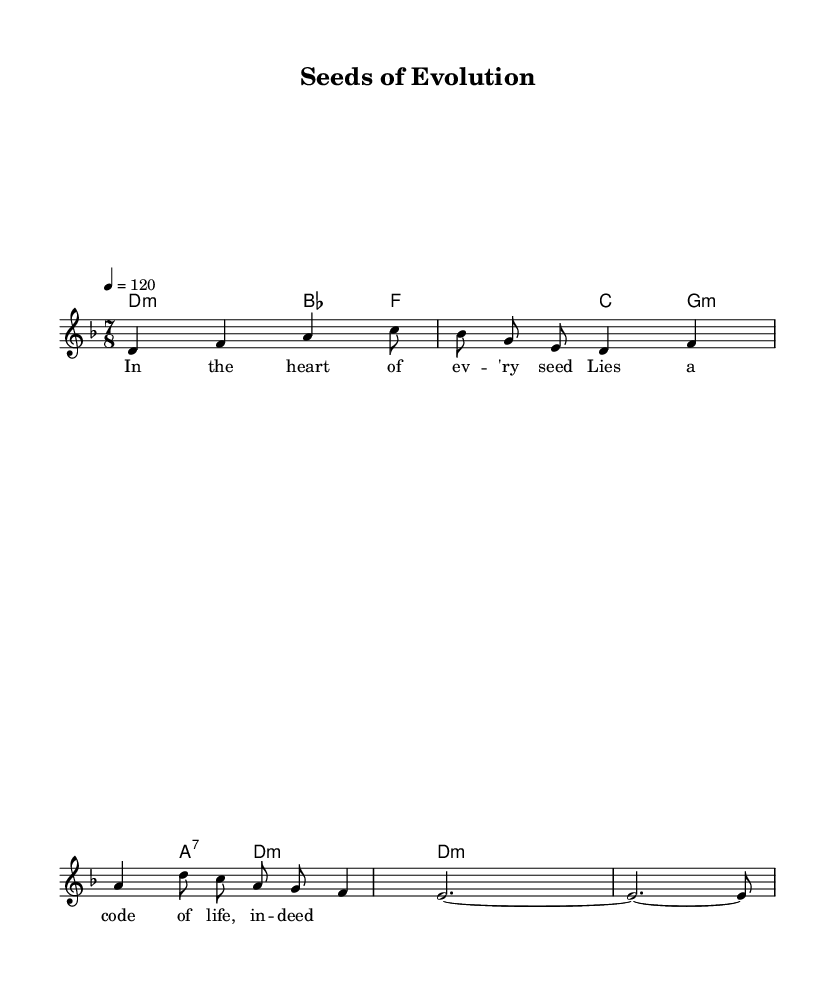What is the key signature of this music? The key signature is indicated at the beginning of the score. It shows that there are two flats: B flat and E flat, which corresponds to D minor, the key signature here.
Answer: D minor What is the time signature of this music? The time signature is located next to the key signature at the beginning of the score. It shows 7/8, indicating that there are seven beats per measure, and the eighth note gets one beat.
Answer: 7/8 What is the tempo marking of this music? The tempo marking is found above the staff, denoting the speed of the piece. It states "4 = 120," meaning there are 120 beats per minute, with a quarter note representing one beat.
Answer: 120 How many measures are in the melody? By counting the total number of measure bars present in the melody line, we find there are six measures.
Answer: 6 What type of chords are in the harmonies section? By analyzing the chord symbols, we can identify the types. The chords listed are D minor, B flat major, F major, G minor, A major 7, and D minor, indicating variations of minor and major chords.
Answer: Minor and Major What is the lyrical theme of the song? The lyrics discuss elements of plant genetics and seed development, emphasizing the life code embedded in every seed, thus reflecting the song’s scientific theme.
Answer: Seed genetics What musical style is predominantly showcased in this score? The structure, time signature, and harmonies, alongside progressive lyrics focusing on a scientific theme, clearly exhibit characteristics of Progressive Rock.
Answer: Progressive Rock 